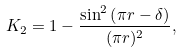<formula> <loc_0><loc_0><loc_500><loc_500>K _ { 2 } = 1 - \frac { \sin ^ { 2 } \left ( \pi r - \delta \right ) } { ( \pi r ) ^ { 2 } } ,</formula> 